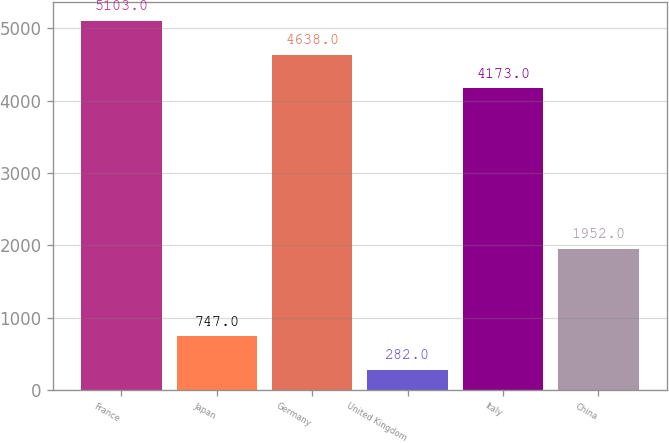Convert chart to OTSL. <chart><loc_0><loc_0><loc_500><loc_500><bar_chart><fcel>France<fcel>Japan<fcel>Germany<fcel>United Kingdom<fcel>Italy<fcel>China<nl><fcel>5103<fcel>747<fcel>4638<fcel>282<fcel>4173<fcel>1952<nl></chart> 